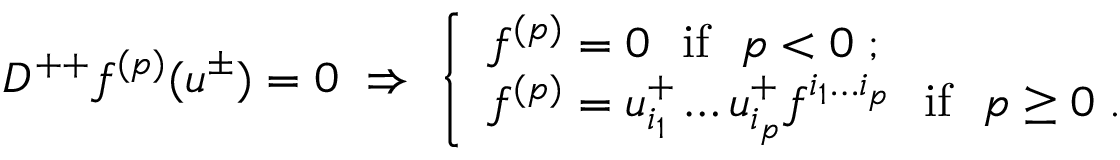<formula> <loc_0><loc_0><loc_500><loc_500>D ^ { + + } f ^ { ( p ) } ( u ^ { \pm } ) = 0 \ \Rightarrow \ \left \{ \begin{array} { l } { { f ^ { ( p ) } = 0 \ \ i f \ \ p < 0 \, ; } } \\ { { f ^ { ( p ) } = u _ { i _ { 1 } } ^ { + } \dots u _ { i _ { p } } ^ { + } f ^ { i _ { 1 } \dots i _ { p } } \ \ i f \ \ p \geq 0 \, . } } \end{array}</formula> 